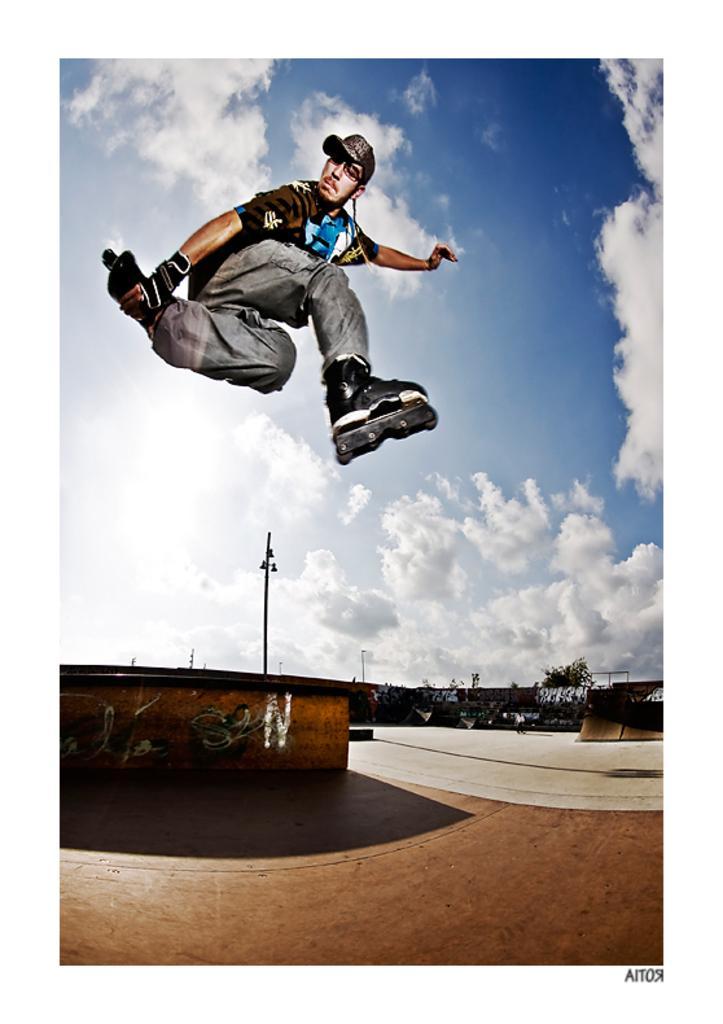In one or two sentences, can you explain what this image depicts? In this image I can see there is a person jumping. And there is a ground and a wall with a painting. And there are trees and a wooden board. And at the top there is a sky. 